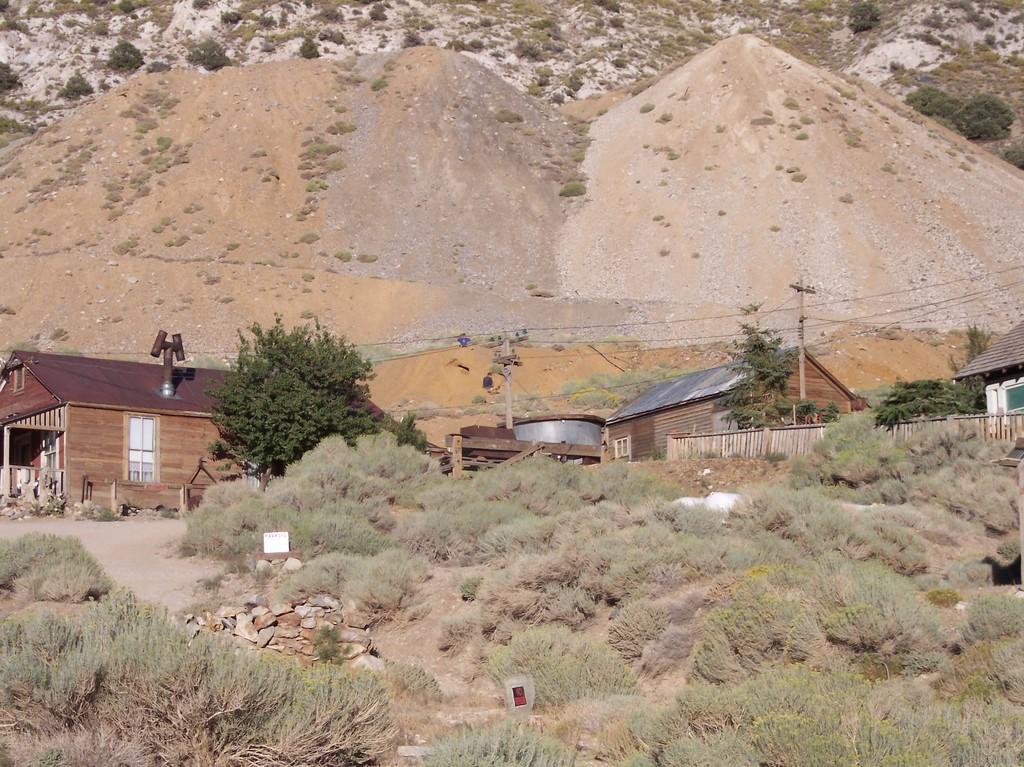Please provide a concise description of this image. In this image we can see plants, fence, poles, houses, trees, stones, and objects. In the background we can see mountains. 